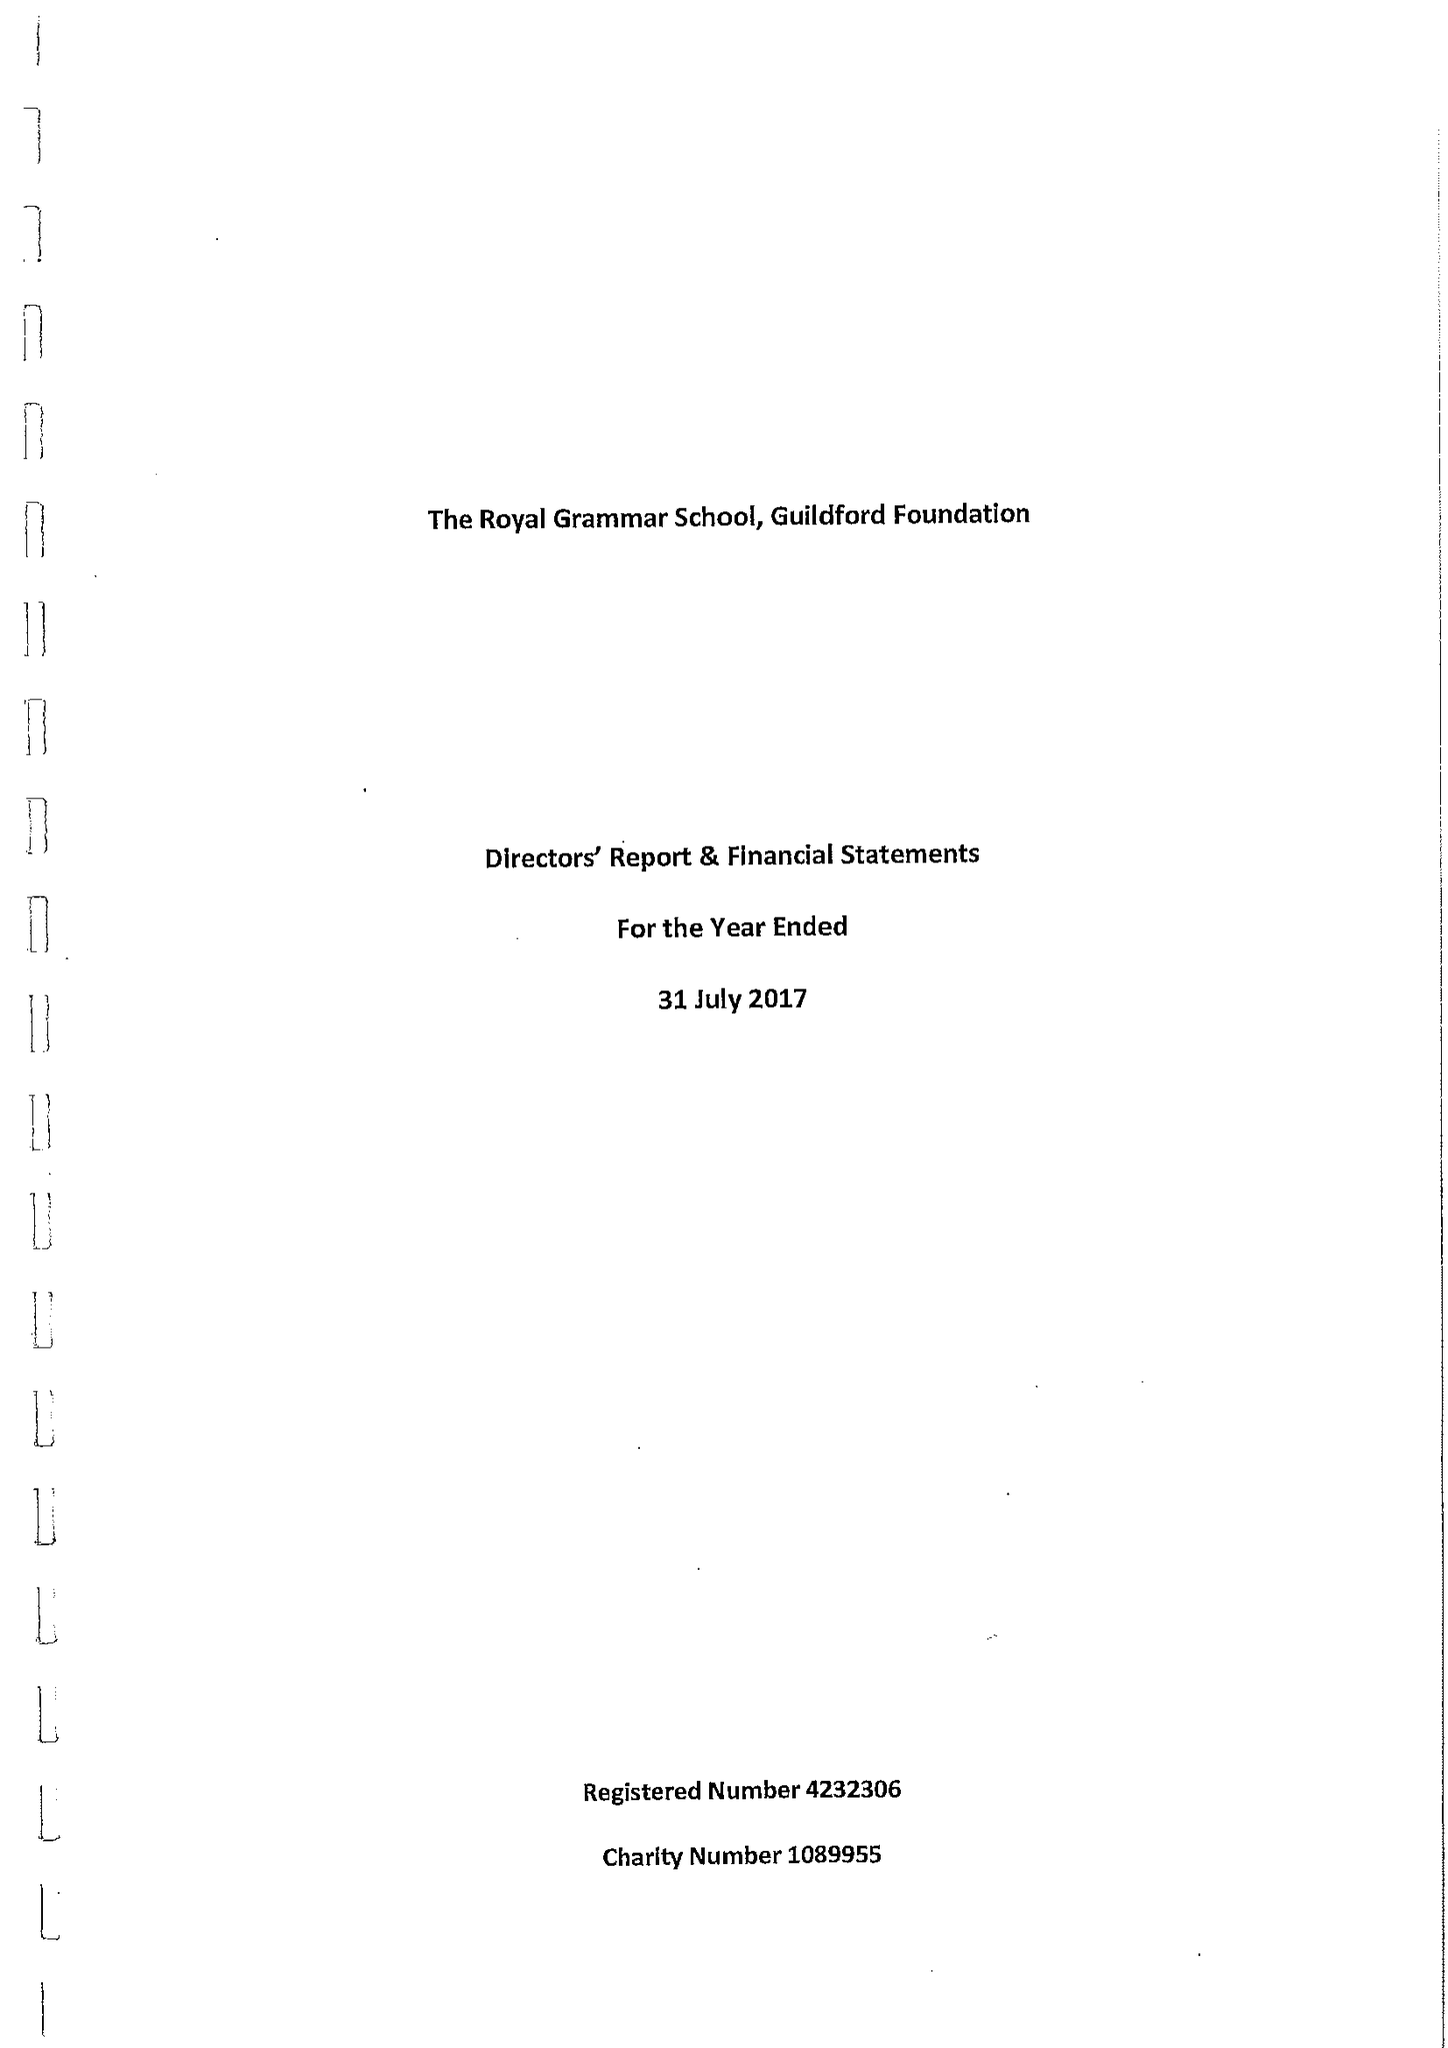What is the value for the address__post_town?
Answer the question using a single word or phrase. GUILDFORD 